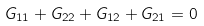<formula> <loc_0><loc_0><loc_500><loc_500>G _ { 1 1 } + G _ { 2 2 } + G _ { 1 2 } + G _ { 2 1 } = 0</formula> 